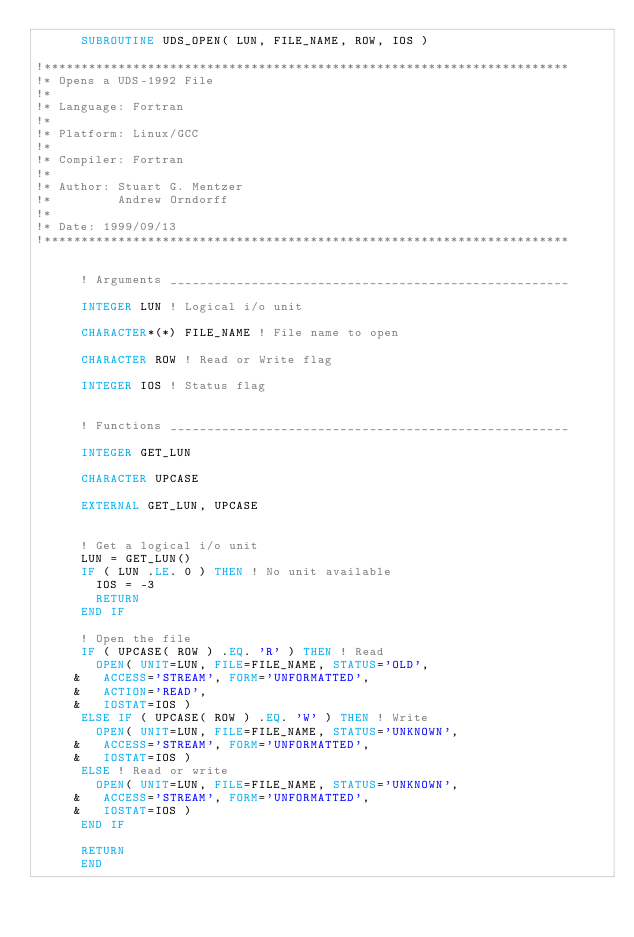Convert code to text. <code><loc_0><loc_0><loc_500><loc_500><_FORTRAN_>      SUBROUTINE UDS_OPEN( LUN, FILE_NAME, ROW, IOS )

!***********************************************************************
!* Opens a UDS-1992 File
!*
!* Language: Fortran
!*
!* Platform: Linux/GCC
!*
!* Compiler: Fortran
!*
!* Author: Stuart G. Mentzer
!*         Andrew Orndorff
!*
!* Date: 1999/09/13
!***********************************************************************


      ! Arguments ______________________________________________________

      INTEGER LUN ! Logical i/o unit

      CHARACTER*(*) FILE_NAME ! File name to open

      CHARACTER ROW ! Read or Write flag

      INTEGER IOS ! Status flag


      ! Functions ______________________________________________________

      INTEGER GET_LUN

      CHARACTER UPCASE

      EXTERNAL GET_LUN, UPCASE


      ! Get a logical i/o unit
      LUN = GET_LUN()
      IF ( LUN .LE. 0 ) THEN ! No unit available
        IOS = -3
        RETURN
      END IF

      ! Open the file
      IF ( UPCASE( ROW ) .EQ. 'R' ) THEN ! Read
        OPEN( UNIT=LUN, FILE=FILE_NAME, STATUS='OLD',
     &   ACCESS='STREAM', FORM='UNFORMATTED',
     &   ACTION='READ',
     &   IOSTAT=IOS )
      ELSE IF ( UPCASE( ROW ) .EQ. 'W' ) THEN ! Write
        OPEN( UNIT=LUN, FILE=FILE_NAME, STATUS='UNKNOWN',
     &   ACCESS='STREAM', FORM='UNFORMATTED',
     &   IOSTAT=IOS )
      ELSE ! Read or write
        OPEN( UNIT=LUN, FILE=FILE_NAME, STATUS='UNKNOWN',
     &   ACCESS='STREAM', FORM='UNFORMATTED',
     &   IOSTAT=IOS )
      END IF

      RETURN
      END
</code> 